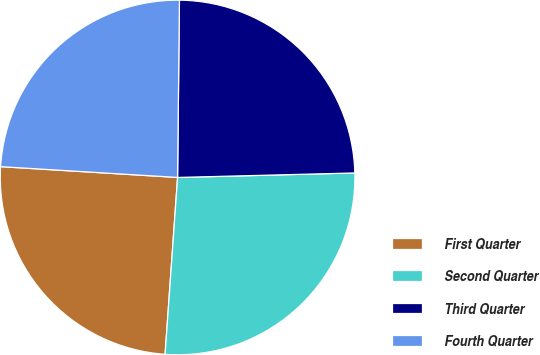<chart> <loc_0><loc_0><loc_500><loc_500><pie_chart><fcel>First Quarter<fcel>Second Quarter<fcel>Third Quarter<fcel>Fourth Quarter<nl><fcel>24.85%<fcel>26.53%<fcel>24.43%<fcel>24.2%<nl></chart> 